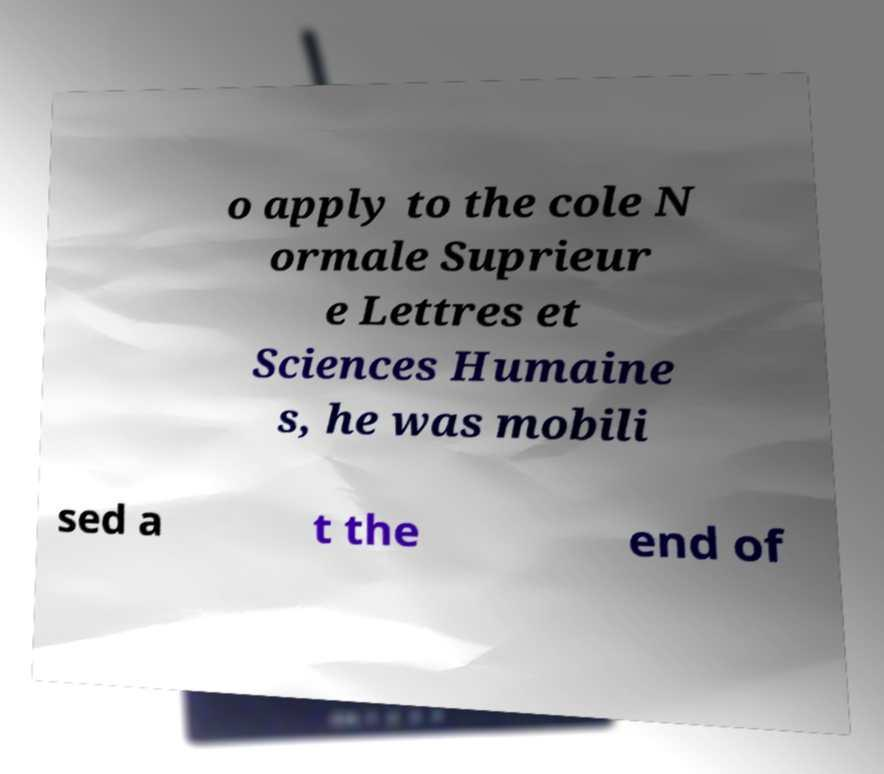Please identify and transcribe the text found in this image. o apply to the cole N ormale Suprieur e Lettres et Sciences Humaine s, he was mobili sed a t the end of 